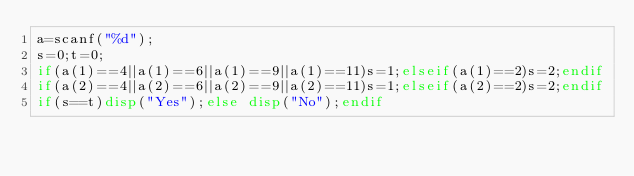Convert code to text. <code><loc_0><loc_0><loc_500><loc_500><_Octave_>a=scanf("%d");
s=0;t=0;
if(a(1)==4||a(1)==6||a(1)==9||a(1)==11)s=1;elseif(a(1)==2)s=2;endif
if(a(2)==4||a(2)==6||a(2)==9||a(2)==11)s=1;elseif(a(2)==2)s=2;endif
if(s==t)disp("Yes");else disp("No");endif</code> 